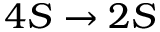Convert formula to latex. <formula><loc_0><loc_0><loc_500><loc_500>4 S \rightarrow 2 S</formula> 